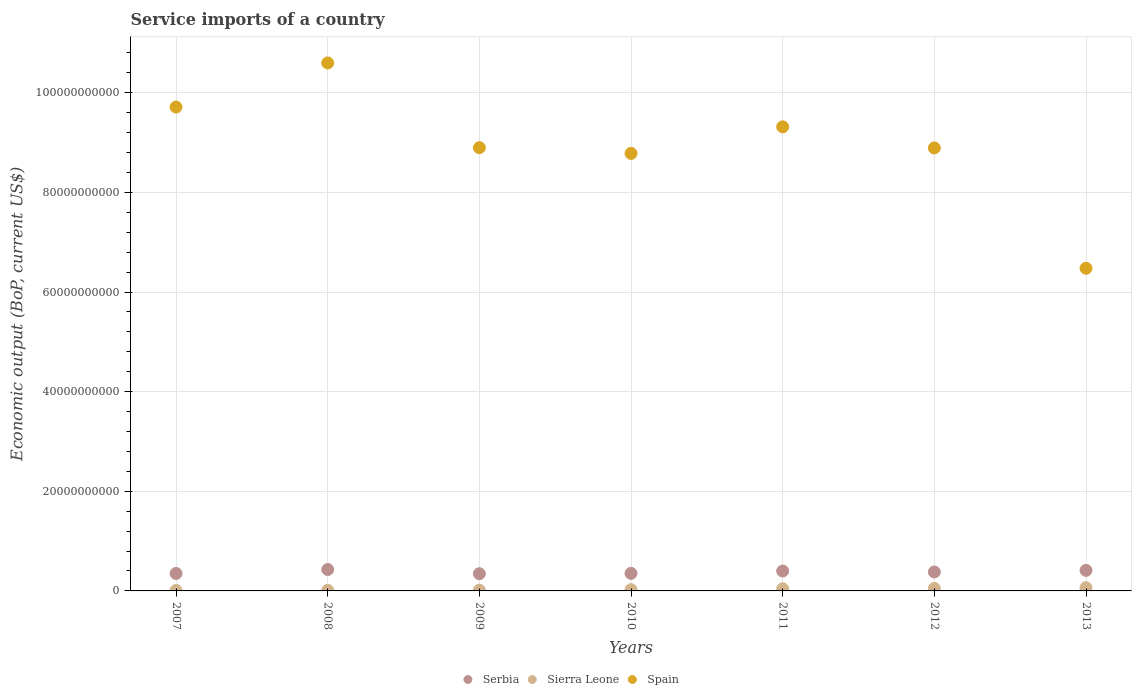Is the number of dotlines equal to the number of legend labels?
Your answer should be compact. Yes. What is the service imports in Serbia in 2010?
Your answer should be very brief. 3.52e+09. Across all years, what is the maximum service imports in Sierra Leone?
Provide a succinct answer. 6.49e+08. Across all years, what is the minimum service imports in Serbia?
Offer a terse response. 3.46e+09. In which year was the service imports in Spain maximum?
Give a very brief answer. 2008. In which year was the service imports in Sierra Leone minimum?
Give a very brief answer. 2007. What is the total service imports in Sierra Leone in the graph?
Your answer should be compact. 2.17e+09. What is the difference between the service imports in Sierra Leone in 2010 and that in 2011?
Give a very brief answer. -1.76e+08. What is the difference between the service imports in Serbia in 2013 and the service imports in Spain in 2007?
Keep it short and to the point. -9.30e+1. What is the average service imports in Sierra Leone per year?
Keep it short and to the point. 3.10e+08. In the year 2013, what is the difference between the service imports in Serbia and service imports in Spain?
Offer a very short reply. -6.06e+1. In how many years, is the service imports in Spain greater than 32000000000 US$?
Your answer should be very brief. 7. What is the ratio of the service imports in Spain in 2008 to that in 2011?
Your answer should be very brief. 1.14. What is the difference between the highest and the second highest service imports in Sierra Leone?
Offer a very short reply. 1.52e+08. What is the difference between the highest and the lowest service imports in Spain?
Ensure brevity in your answer.  4.12e+1. Does the service imports in Spain monotonically increase over the years?
Provide a short and direct response. No. Is the service imports in Spain strictly less than the service imports in Sierra Leone over the years?
Keep it short and to the point. No. Are the values on the major ticks of Y-axis written in scientific E-notation?
Provide a short and direct response. No. How many legend labels are there?
Your answer should be compact. 3. What is the title of the graph?
Ensure brevity in your answer.  Service imports of a country. Does "Chad" appear as one of the legend labels in the graph?
Your response must be concise. No. What is the label or title of the Y-axis?
Your answer should be compact. Economic output (BoP, current US$). What is the Economic output (BoP, current US$) in Serbia in 2007?
Your answer should be very brief. 3.51e+09. What is the Economic output (BoP, current US$) in Sierra Leone in 2007?
Make the answer very short. 9.43e+07. What is the Economic output (BoP, current US$) of Spain in 2007?
Your answer should be very brief. 9.71e+1. What is the Economic output (BoP, current US$) in Serbia in 2008?
Give a very brief answer. 4.30e+09. What is the Economic output (BoP, current US$) of Sierra Leone in 2008?
Your answer should be compact. 1.21e+08. What is the Economic output (BoP, current US$) of Spain in 2008?
Provide a short and direct response. 1.06e+11. What is the Economic output (BoP, current US$) in Serbia in 2009?
Your answer should be compact. 3.46e+09. What is the Economic output (BoP, current US$) in Sierra Leone in 2009?
Provide a succinct answer. 1.32e+08. What is the Economic output (BoP, current US$) in Spain in 2009?
Offer a very short reply. 8.90e+1. What is the Economic output (BoP, current US$) of Serbia in 2010?
Offer a very short reply. 3.52e+09. What is the Economic output (BoP, current US$) in Sierra Leone in 2010?
Your response must be concise. 2.52e+08. What is the Economic output (BoP, current US$) in Spain in 2010?
Your answer should be very brief. 8.78e+1. What is the Economic output (BoP, current US$) in Serbia in 2011?
Offer a very short reply. 3.99e+09. What is the Economic output (BoP, current US$) of Sierra Leone in 2011?
Offer a very short reply. 4.28e+08. What is the Economic output (BoP, current US$) of Spain in 2011?
Your response must be concise. 9.32e+1. What is the Economic output (BoP, current US$) in Serbia in 2012?
Keep it short and to the point. 3.81e+09. What is the Economic output (BoP, current US$) in Sierra Leone in 2012?
Offer a terse response. 4.97e+08. What is the Economic output (BoP, current US$) in Spain in 2012?
Provide a short and direct response. 8.89e+1. What is the Economic output (BoP, current US$) of Serbia in 2013?
Your answer should be very brief. 4.12e+09. What is the Economic output (BoP, current US$) of Sierra Leone in 2013?
Your answer should be compact. 6.49e+08. What is the Economic output (BoP, current US$) in Spain in 2013?
Your response must be concise. 6.48e+1. Across all years, what is the maximum Economic output (BoP, current US$) of Serbia?
Your answer should be very brief. 4.30e+09. Across all years, what is the maximum Economic output (BoP, current US$) in Sierra Leone?
Give a very brief answer. 6.49e+08. Across all years, what is the maximum Economic output (BoP, current US$) of Spain?
Offer a terse response. 1.06e+11. Across all years, what is the minimum Economic output (BoP, current US$) of Serbia?
Offer a very short reply. 3.46e+09. Across all years, what is the minimum Economic output (BoP, current US$) in Sierra Leone?
Offer a very short reply. 9.43e+07. Across all years, what is the minimum Economic output (BoP, current US$) of Spain?
Keep it short and to the point. 6.48e+1. What is the total Economic output (BoP, current US$) of Serbia in the graph?
Offer a terse response. 2.67e+1. What is the total Economic output (BoP, current US$) of Sierra Leone in the graph?
Offer a very short reply. 2.17e+09. What is the total Economic output (BoP, current US$) of Spain in the graph?
Provide a succinct answer. 6.27e+11. What is the difference between the Economic output (BoP, current US$) in Serbia in 2007 and that in 2008?
Your answer should be very brief. -7.91e+08. What is the difference between the Economic output (BoP, current US$) of Sierra Leone in 2007 and that in 2008?
Provide a short and direct response. -2.66e+07. What is the difference between the Economic output (BoP, current US$) of Spain in 2007 and that in 2008?
Your response must be concise. -8.86e+09. What is the difference between the Economic output (BoP, current US$) of Serbia in 2007 and that in 2009?
Give a very brief answer. 4.96e+07. What is the difference between the Economic output (BoP, current US$) of Sierra Leone in 2007 and that in 2009?
Your answer should be compact. -3.78e+07. What is the difference between the Economic output (BoP, current US$) of Spain in 2007 and that in 2009?
Offer a terse response. 8.15e+09. What is the difference between the Economic output (BoP, current US$) of Serbia in 2007 and that in 2010?
Give a very brief answer. -1.85e+07. What is the difference between the Economic output (BoP, current US$) in Sierra Leone in 2007 and that in 2010?
Your answer should be compact. -1.57e+08. What is the difference between the Economic output (BoP, current US$) in Spain in 2007 and that in 2010?
Your answer should be very brief. 9.30e+09. What is the difference between the Economic output (BoP, current US$) of Serbia in 2007 and that in 2011?
Keep it short and to the point. -4.89e+08. What is the difference between the Economic output (BoP, current US$) of Sierra Leone in 2007 and that in 2011?
Your answer should be compact. -3.33e+08. What is the difference between the Economic output (BoP, current US$) in Spain in 2007 and that in 2011?
Provide a succinct answer. 3.97e+09. What is the difference between the Economic output (BoP, current US$) of Serbia in 2007 and that in 2012?
Give a very brief answer. -3.03e+08. What is the difference between the Economic output (BoP, current US$) of Sierra Leone in 2007 and that in 2012?
Offer a terse response. -4.03e+08. What is the difference between the Economic output (BoP, current US$) in Spain in 2007 and that in 2012?
Give a very brief answer. 8.20e+09. What is the difference between the Economic output (BoP, current US$) in Serbia in 2007 and that in 2013?
Your answer should be very brief. -6.19e+08. What is the difference between the Economic output (BoP, current US$) in Sierra Leone in 2007 and that in 2013?
Ensure brevity in your answer.  -5.55e+08. What is the difference between the Economic output (BoP, current US$) in Spain in 2007 and that in 2013?
Make the answer very short. 3.24e+1. What is the difference between the Economic output (BoP, current US$) in Serbia in 2008 and that in 2009?
Make the answer very short. 8.40e+08. What is the difference between the Economic output (BoP, current US$) in Sierra Leone in 2008 and that in 2009?
Provide a short and direct response. -1.11e+07. What is the difference between the Economic output (BoP, current US$) of Spain in 2008 and that in 2009?
Give a very brief answer. 1.70e+1. What is the difference between the Economic output (BoP, current US$) of Serbia in 2008 and that in 2010?
Make the answer very short. 7.72e+08. What is the difference between the Economic output (BoP, current US$) in Sierra Leone in 2008 and that in 2010?
Offer a terse response. -1.31e+08. What is the difference between the Economic output (BoP, current US$) in Spain in 2008 and that in 2010?
Offer a terse response. 1.82e+1. What is the difference between the Economic output (BoP, current US$) in Serbia in 2008 and that in 2011?
Offer a terse response. 3.01e+08. What is the difference between the Economic output (BoP, current US$) of Sierra Leone in 2008 and that in 2011?
Offer a very short reply. -3.07e+08. What is the difference between the Economic output (BoP, current US$) in Spain in 2008 and that in 2011?
Provide a succinct answer. 1.28e+1. What is the difference between the Economic output (BoP, current US$) in Serbia in 2008 and that in 2012?
Ensure brevity in your answer.  4.87e+08. What is the difference between the Economic output (BoP, current US$) in Sierra Leone in 2008 and that in 2012?
Keep it short and to the point. -3.76e+08. What is the difference between the Economic output (BoP, current US$) in Spain in 2008 and that in 2012?
Keep it short and to the point. 1.71e+1. What is the difference between the Economic output (BoP, current US$) in Serbia in 2008 and that in 2013?
Give a very brief answer. 1.72e+08. What is the difference between the Economic output (BoP, current US$) in Sierra Leone in 2008 and that in 2013?
Offer a terse response. -5.28e+08. What is the difference between the Economic output (BoP, current US$) of Spain in 2008 and that in 2013?
Provide a short and direct response. 4.12e+1. What is the difference between the Economic output (BoP, current US$) in Serbia in 2009 and that in 2010?
Your answer should be very brief. -6.81e+07. What is the difference between the Economic output (BoP, current US$) in Sierra Leone in 2009 and that in 2010?
Offer a terse response. -1.20e+08. What is the difference between the Economic output (BoP, current US$) of Spain in 2009 and that in 2010?
Make the answer very short. 1.15e+09. What is the difference between the Economic output (BoP, current US$) in Serbia in 2009 and that in 2011?
Offer a terse response. -5.39e+08. What is the difference between the Economic output (BoP, current US$) in Sierra Leone in 2009 and that in 2011?
Your response must be concise. -2.96e+08. What is the difference between the Economic output (BoP, current US$) of Spain in 2009 and that in 2011?
Offer a terse response. -4.18e+09. What is the difference between the Economic output (BoP, current US$) of Serbia in 2009 and that in 2012?
Your response must be concise. -3.53e+08. What is the difference between the Economic output (BoP, current US$) of Sierra Leone in 2009 and that in 2012?
Offer a very short reply. -3.65e+08. What is the difference between the Economic output (BoP, current US$) in Spain in 2009 and that in 2012?
Offer a terse response. 5.04e+07. What is the difference between the Economic output (BoP, current US$) of Serbia in 2009 and that in 2013?
Keep it short and to the point. -6.68e+08. What is the difference between the Economic output (BoP, current US$) of Sierra Leone in 2009 and that in 2013?
Provide a short and direct response. -5.17e+08. What is the difference between the Economic output (BoP, current US$) of Spain in 2009 and that in 2013?
Ensure brevity in your answer.  2.42e+1. What is the difference between the Economic output (BoP, current US$) of Serbia in 2010 and that in 2011?
Keep it short and to the point. -4.71e+08. What is the difference between the Economic output (BoP, current US$) in Sierra Leone in 2010 and that in 2011?
Give a very brief answer. -1.76e+08. What is the difference between the Economic output (BoP, current US$) in Spain in 2010 and that in 2011?
Your response must be concise. -5.33e+09. What is the difference between the Economic output (BoP, current US$) in Serbia in 2010 and that in 2012?
Offer a terse response. -2.85e+08. What is the difference between the Economic output (BoP, current US$) of Sierra Leone in 2010 and that in 2012?
Your response must be concise. -2.46e+08. What is the difference between the Economic output (BoP, current US$) in Spain in 2010 and that in 2012?
Provide a short and direct response. -1.10e+09. What is the difference between the Economic output (BoP, current US$) of Serbia in 2010 and that in 2013?
Give a very brief answer. -6.00e+08. What is the difference between the Economic output (BoP, current US$) in Sierra Leone in 2010 and that in 2013?
Provide a succinct answer. -3.97e+08. What is the difference between the Economic output (BoP, current US$) in Spain in 2010 and that in 2013?
Your answer should be compact. 2.31e+1. What is the difference between the Economic output (BoP, current US$) of Serbia in 2011 and that in 2012?
Offer a very short reply. 1.86e+08. What is the difference between the Economic output (BoP, current US$) of Sierra Leone in 2011 and that in 2012?
Give a very brief answer. -6.97e+07. What is the difference between the Economic output (BoP, current US$) in Spain in 2011 and that in 2012?
Ensure brevity in your answer.  4.23e+09. What is the difference between the Economic output (BoP, current US$) of Serbia in 2011 and that in 2013?
Your answer should be very brief. -1.30e+08. What is the difference between the Economic output (BoP, current US$) in Sierra Leone in 2011 and that in 2013?
Offer a terse response. -2.21e+08. What is the difference between the Economic output (BoP, current US$) of Spain in 2011 and that in 2013?
Make the answer very short. 2.84e+1. What is the difference between the Economic output (BoP, current US$) of Serbia in 2012 and that in 2013?
Your answer should be very brief. -3.15e+08. What is the difference between the Economic output (BoP, current US$) in Sierra Leone in 2012 and that in 2013?
Give a very brief answer. -1.52e+08. What is the difference between the Economic output (BoP, current US$) of Spain in 2012 and that in 2013?
Your answer should be very brief. 2.42e+1. What is the difference between the Economic output (BoP, current US$) in Serbia in 2007 and the Economic output (BoP, current US$) in Sierra Leone in 2008?
Provide a short and direct response. 3.38e+09. What is the difference between the Economic output (BoP, current US$) in Serbia in 2007 and the Economic output (BoP, current US$) in Spain in 2008?
Offer a terse response. -1.02e+11. What is the difference between the Economic output (BoP, current US$) in Sierra Leone in 2007 and the Economic output (BoP, current US$) in Spain in 2008?
Ensure brevity in your answer.  -1.06e+11. What is the difference between the Economic output (BoP, current US$) of Serbia in 2007 and the Economic output (BoP, current US$) of Sierra Leone in 2009?
Your answer should be compact. 3.37e+09. What is the difference between the Economic output (BoP, current US$) in Serbia in 2007 and the Economic output (BoP, current US$) in Spain in 2009?
Ensure brevity in your answer.  -8.55e+1. What is the difference between the Economic output (BoP, current US$) in Sierra Leone in 2007 and the Economic output (BoP, current US$) in Spain in 2009?
Provide a short and direct response. -8.89e+1. What is the difference between the Economic output (BoP, current US$) of Serbia in 2007 and the Economic output (BoP, current US$) of Sierra Leone in 2010?
Your answer should be very brief. 3.25e+09. What is the difference between the Economic output (BoP, current US$) in Serbia in 2007 and the Economic output (BoP, current US$) in Spain in 2010?
Provide a short and direct response. -8.43e+1. What is the difference between the Economic output (BoP, current US$) of Sierra Leone in 2007 and the Economic output (BoP, current US$) of Spain in 2010?
Make the answer very short. -8.77e+1. What is the difference between the Economic output (BoP, current US$) in Serbia in 2007 and the Economic output (BoP, current US$) in Sierra Leone in 2011?
Your response must be concise. 3.08e+09. What is the difference between the Economic output (BoP, current US$) in Serbia in 2007 and the Economic output (BoP, current US$) in Spain in 2011?
Offer a terse response. -8.97e+1. What is the difference between the Economic output (BoP, current US$) in Sierra Leone in 2007 and the Economic output (BoP, current US$) in Spain in 2011?
Offer a terse response. -9.31e+1. What is the difference between the Economic output (BoP, current US$) in Serbia in 2007 and the Economic output (BoP, current US$) in Sierra Leone in 2012?
Give a very brief answer. 3.01e+09. What is the difference between the Economic output (BoP, current US$) of Serbia in 2007 and the Economic output (BoP, current US$) of Spain in 2012?
Make the answer very short. -8.54e+1. What is the difference between the Economic output (BoP, current US$) of Sierra Leone in 2007 and the Economic output (BoP, current US$) of Spain in 2012?
Keep it short and to the point. -8.88e+1. What is the difference between the Economic output (BoP, current US$) in Serbia in 2007 and the Economic output (BoP, current US$) in Sierra Leone in 2013?
Your answer should be very brief. 2.86e+09. What is the difference between the Economic output (BoP, current US$) in Serbia in 2007 and the Economic output (BoP, current US$) in Spain in 2013?
Your response must be concise. -6.13e+1. What is the difference between the Economic output (BoP, current US$) of Sierra Leone in 2007 and the Economic output (BoP, current US$) of Spain in 2013?
Keep it short and to the point. -6.47e+1. What is the difference between the Economic output (BoP, current US$) of Serbia in 2008 and the Economic output (BoP, current US$) of Sierra Leone in 2009?
Offer a terse response. 4.16e+09. What is the difference between the Economic output (BoP, current US$) in Serbia in 2008 and the Economic output (BoP, current US$) in Spain in 2009?
Make the answer very short. -8.47e+1. What is the difference between the Economic output (BoP, current US$) of Sierra Leone in 2008 and the Economic output (BoP, current US$) of Spain in 2009?
Give a very brief answer. -8.89e+1. What is the difference between the Economic output (BoP, current US$) in Serbia in 2008 and the Economic output (BoP, current US$) in Sierra Leone in 2010?
Your answer should be very brief. 4.04e+09. What is the difference between the Economic output (BoP, current US$) in Serbia in 2008 and the Economic output (BoP, current US$) in Spain in 2010?
Give a very brief answer. -8.35e+1. What is the difference between the Economic output (BoP, current US$) of Sierra Leone in 2008 and the Economic output (BoP, current US$) of Spain in 2010?
Provide a succinct answer. -8.77e+1. What is the difference between the Economic output (BoP, current US$) in Serbia in 2008 and the Economic output (BoP, current US$) in Sierra Leone in 2011?
Ensure brevity in your answer.  3.87e+09. What is the difference between the Economic output (BoP, current US$) of Serbia in 2008 and the Economic output (BoP, current US$) of Spain in 2011?
Offer a very short reply. -8.89e+1. What is the difference between the Economic output (BoP, current US$) in Sierra Leone in 2008 and the Economic output (BoP, current US$) in Spain in 2011?
Make the answer very short. -9.30e+1. What is the difference between the Economic output (BoP, current US$) of Serbia in 2008 and the Economic output (BoP, current US$) of Sierra Leone in 2012?
Offer a terse response. 3.80e+09. What is the difference between the Economic output (BoP, current US$) in Serbia in 2008 and the Economic output (BoP, current US$) in Spain in 2012?
Offer a very short reply. -8.46e+1. What is the difference between the Economic output (BoP, current US$) in Sierra Leone in 2008 and the Economic output (BoP, current US$) in Spain in 2012?
Your response must be concise. -8.88e+1. What is the difference between the Economic output (BoP, current US$) in Serbia in 2008 and the Economic output (BoP, current US$) in Sierra Leone in 2013?
Offer a terse response. 3.65e+09. What is the difference between the Economic output (BoP, current US$) in Serbia in 2008 and the Economic output (BoP, current US$) in Spain in 2013?
Ensure brevity in your answer.  -6.05e+1. What is the difference between the Economic output (BoP, current US$) of Sierra Leone in 2008 and the Economic output (BoP, current US$) of Spain in 2013?
Provide a succinct answer. -6.46e+1. What is the difference between the Economic output (BoP, current US$) in Serbia in 2009 and the Economic output (BoP, current US$) in Sierra Leone in 2010?
Your answer should be compact. 3.20e+09. What is the difference between the Economic output (BoP, current US$) of Serbia in 2009 and the Economic output (BoP, current US$) of Spain in 2010?
Ensure brevity in your answer.  -8.44e+1. What is the difference between the Economic output (BoP, current US$) in Sierra Leone in 2009 and the Economic output (BoP, current US$) in Spain in 2010?
Give a very brief answer. -8.77e+1. What is the difference between the Economic output (BoP, current US$) in Serbia in 2009 and the Economic output (BoP, current US$) in Sierra Leone in 2011?
Give a very brief answer. 3.03e+09. What is the difference between the Economic output (BoP, current US$) of Serbia in 2009 and the Economic output (BoP, current US$) of Spain in 2011?
Provide a succinct answer. -8.97e+1. What is the difference between the Economic output (BoP, current US$) of Sierra Leone in 2009 and the Economic output (BoP, current US$) of Spain in 2011?
Offer a very short reply. -9.30e+1. What is the difference between the Economic output (BoP, current US$) in Serbia in 2009 and the Economic output (BoP, current US$) in Sierra Leone in 2012?
Your answer should be compact. 2.96e+09. What is the difference between the Economic output (BoP, current US$) of Serbia in 2009 and the Economic output (BoP, current US$) of Spain in 2012?
Keep it short and to the point. -8.55e+1. What is the difference between the Economic output (BoP, current US$) of Sierra Leone in 2009 and the Economic output (BoP, current US$) of Spain in 2012?
Your response must be concise. -8.88e+1. What is the difference between the Economic output (BoP, current US$) of Serbia in 2009 and the Economic output (BoP, current US$) of Sierra Leone in 2013?
Your answer should be compact. 2.81e+09. What is the difference between the Economic output (BoP, current US$) of Serbia in 2009 and the Economic output (BoP, current US$) of Spain in 2013?
Your answer should be very brief. -6.13e+1. What is the difference between the Economic output (BoP, current US$) in Sierra Leone in 2009 and the Economic output (BoP, current US$) in Spain in 2013?
Make the answer very short. -6.46e+1. What is the difference between the Economic output (BoP, current US$) in Serbia in 2010 and the Economic output (BoP, current US$) in Sierra Leone in 2011?
Ensure brevity in your answer.  3.10e+09. What is the difference between the Economic output (BoP, current US$) in Serbia in 2010 and the Economic output (BoP, current US$) in Spain in 2011?
Provide a succinct answer. -8.96e+1. What is the difference between the Economic output (BoP, current US$) of Sierra Leone in 2010 and the Economic output (BoP, current US$) of Spain in 2011?
Offer a very short reply. -9.29e+1. What is the difference between the Economic output (BoP, current US$) of Serbia in 2010 and the Economic output (BoP, current US$) of Sierra Leone in 2012?
Offer a very short reply. 3.03e+09. What is the difference between the Economic output (BoP, current US$) in Serbia in 2010 and the Economic output (BoP, current US$) in Spain in 2012?
Offer a terse response. -8.54e+1. What is the difference between the Economic output (BoP, current US$) of Sierra Leone in 2010 and the Economic output (BoP, current US$) of Spain in 2012?
Your answer should be very brief. -8.87e+1. What is the difference between the Economic output (BoP, current US$) in Serbia in 2010 and the Economic output (BoP, current US$) in Sierra Leone in 2013?
Make the answer very short. 2.88e+09. What is the difference between the Economic output (BoP, current US$) in Serbia in 2010 and the Economic output (BoP, current US$) in Spain in 2013?
Provide a short and direct response. -6.12e+1. What is the difference between the Economic output (BoP, current US$) in Sierra Leone in 2010 and the Economic output (BoP, current US$) in Spain in 2013?
Your response must be concise. -6.45e+1. What is the difference between the Economic output (BoP, current US$) in Serbia in 2011 and the Economic output (BoP, current US$) in Sierra Leone in 2012?
Your response must be concise. 3.50e+09. What is the difference between the Economic output (BoP, current US$) of Serbia in 2011 and the Economic output (BoP, current US$) of Spain in 2012?
Give a very brief answer. -8.49e+1. What is the difference between the Economic output (BoP, current US$) in Sierra Leone in 2011 and the Economic output (BoP, current US$) in Spain in 2012?
Your answer should be compact. -8.85e+1. What is the difference between the Economic output (BoP, current US$) in Serbia in 2011 and the Economic output (BoP, current US$) in Sierra Leone in 2013?
Ensure brevity in your answer.  3.35e+09. What is the difference between the Economic output (BoP, current US$) in Serbia in 2011 and the Economic output (BoP, current US$) in Spain in 2013?
Your answer should be compact. -6.08e+1. What is the difference between the Economic output (BoP, current US$) in Sierra Leone in 2011 and the Economic output (BoP, current US$) in Spain in 2013?
Make the answer very short. -6.43e+1. What is the difference between the Economic output (BoP, current US$) in Serbia in 2012 and the Economic output (BoP, current US$) in Sierra Leone in 2013?
Provide a short and direct response. 3.16e+09. What is the difference between the Economic output (BoP, current US$) of Serbia in 2012 and the Economic output (BoP, current US$) of Spain in 2013?
Provide a short and direct response. -6.10e+1. What is the difference between the Economic output (BoP, current US$) of Sierra Leone in 2012 and the Economic output (BoP, current US$) of Spain in 2013?
Offer a terse response. -6.43e+1. What is the average Economic output (BoP, current US$) of Serbia per year?
Ensure brevity in your answer.  3.82e+09. What is the average Economic output (BoP, current US$) in Sierra Leone per year?
Provide a short and direct response. 3.10e+08. What is the average Economic output (BoP, current US$) of Spain per year?
Provide a short and direct response. 8.95e+1. In the year 2007, what is the difference between the Economic output (BoP, current US$) of Serbia and Economic output (BoP, current US$) of Sierra Leone?
Keep it short and to the point. 3.41e+09. In the year 2007, what is the difference between the Economic output (BoP, current US$) in Serbia and Economic output (BoP, current US$) in Spain?
Provide a succinct answer. -9.36e+1. In the year 2007, what is the difference between the Economic output (BoP, current US$) in Sierra Leone and Economic output (BoP, current US$) in Spain?
Give a very brief answer. -9.70e+1. In the year 2008, what is the difference between the Economic output (BoP, current US$) in Serbia and Economic output (BoP, current US$) in Sierra Leone?
Ensure brevity in your answer.  4.18e+09. In the year 2008, what is the difference between the Economic output (BoP, current US$) of Serbia and Economic output (BoP, current US$) of Spain?
Provide a short and direct response. -1.02e+11. In the year 2008, what is the difference between the Economic output (BoP, current US$) of Sierra Leone and Economic output (BoP, current US$) of Spain?
Your answer should be compact. -1.06e+11. In the year 2009, what is the difference between the Economic output (BoP, current US$) in Serbia and Economic output (BoP, current US$) in Sierra Leone?
Ensure brevity in your answer.  3.32e+09. In the year 2009, what is the difference between the Economic output (BoP, current US$) in Serbia and Economic output (BoP, current US$) in Spain?
Your answer should be very brief. -8.55e+1. In the year 2009, what is the difference between the Economic output (BoP, current US$) in Sierra Leone and Economic output (BoP, current US$) in Spain?
Offer a very short reply. -8.88e+1. In the year 2010, what is the difference between the Economic output (BoP, current US$) of Serbia and Economic output (BoP, current US$) of Sierra Leone?
Provide a short and direct response. 3.27e+09. In the year 2010, what is the difference between the Economic output (BoP, current US$) of Serbia and Economic output (BoP, current US$) of Spain?
Offer a very short reply. -8.43e+1. In the year 2010, what is the difference between the Economic output (BoP, current US$) of Sierra Leone and Economic output (BoP, current US$) of Spain?
Give a very brief answer. -8.76e+1. In the year 2011, what is the difference between the Economic output (BoP, current US$) of Serbia and Economic output (BoP, current US$) of Sierra Leone?
Your response must be concise. 3.57e+09. In the year 2011, what is the difference between the Economic output (BoP, current US$) in Serbia and Economic output (BoP, current US$) in Spain?
Give a very brief answer. -8.92e+1. In the year 2011, what is the difference between the Economic output (BoP, current US$) of Sierra Leone and Economic output (BoP, current US$) of Spain?
Ensure brevity in your answer.  -9.27e+1. In the year 2012, what is the difference between the Economic output (BoP, current US$) in Serbia and Economic output (BoP, current US$) in Sierra Leone?
Ensure brevity in your answer.  3.31e+09. In the year 2012, what is the difference between the Economic output (BoP, current US$) in Serbia and Economic output (BoP, current US$) in Spain?
Give a very brief answer. -8.51e+1. In the year 2012, what is the difference between the Economic output (BoP, current US$) in Sierra Leone and Economic output (BoP, current US$) in Spain?
Give a very brief answer. -8.84e+1. In the year 2013, what is the difference between the Economic output (BoP, current US$) of Serbia and Economic output (BoP, current US$) of Sierra Leone?
Your response must be concise. 3.48e+09. In the year 2013, what is the difference between the Economic output (BoP, current US$) in Serbia and Economic output (BoP, current US$) in Spain?
Your response must be concise. -6.06e+1. In the year 2013, what is the difference between the Economic output (BoP, current US$) of Sierra Leone and Economic output (BoP, current US$) of Spain?
Your answer should be compact. -6.41e+1. What is the ratio of the Economic output (BoP, current US$) in Serbia in 2007 to that in 2008?
Offer a very short reply. 0.82. What is the ratio of the Economic output (BoP, current US$) of Sierra Leone in 2007 to that in 2008?
Your answer should be very brief. 0.78. What is the ratio of the Economic output (BoP, current US$) of Spain in 2007 to that in 2008?
Provide a short and direct response. 0.92. What is the ratio of the Economic output (BoP, current US$) in Serbia in 2007 to that in 2009?
Provide a succinct answer. 1.01. What is the ratio of the Economic output (BoP, current US$) of Sierra Leone in 2007 to that in 2009?
Offer a very short reply. 0.71. What is the ratio of the Economic output (BoP, current US$) of Spain in 2007 to that in 2009?
Your response must be concise. 1.09. What is the ratio of the Economic output (BoP, current US$) of Serbia in 2007 to that in 2010?
Provide a short and direct response. 0.99. What is the ratio of the Economic output (BoP, current US$) in Sierra Leone in 2007 to that in 2010?
Provide a short and direct response. 0.37. What is the ratio of the Economic output (BoP, current US$) of Spain in 2007 to that in 2010?
Provide a short and direct response. 1.11. What is the ratio of the Economic output (BoP, current US$) in Serbia in 2007 to that in 2011?
Your answer should be compact. 0.88. What is the ratio of the Economic output (BoP, current US$) of Sierra Leone in 2007 to that in 2011?
Your answer should be very brief. 0.22. What is the ratio of the Economic output (BoP, current US$) in Spain in 2007 to that in 2011?
Provide a short and direct response. 1.04. What is the ratio of the Economic output (BoP, current US$) in Serbia in 2007 to that in 2012?
Provide a short and direct response. 0.92. What is the ratio of the Economic output (BoP, current US$) in Sierra Leone in 2007 to that in 2012?
Provide a short and direct response. 0.19. What is the ratio of the Economic output (BoP, current US$) of Spain in 2007 to that in 2012?
Offer a very short reply. 1.09. What is the ratio of the Economic output (BoP, current US$) in Sierra Leone in 2007 to that in 2013?
Keep it short and to the point. 0.15. What is the ratio of the Economic output (BoP, current US$) in Spain in 2007 to that in 2013?
Provide a short and direct response. 1.5. What is the ratio of the Economic output (BoP, current US$) of Serbia in 2008 to that in 2009?
Your answer should be very brief. 1.24. What is the ratio of the Economic output (BoP, current US$) in Sierra Leone in 2008 to that in 2009?
Provide a short and direct response. 0.92. What is the ratio of the Economic output (BoP, current US$) in Spain in 2008 to that in 2009?
Provide a short and direct response. 1.19. What is the ratio of the Economic output (BoP, current US$) in Serbia in 2008 to that in 2010?
Provide a short and direct response. 1.22. What is the ratio of the Economic output (BoP, current US$) of Sierra Leone in 2008 to that in 2010?
Your answer should be very brief. 0.48. What is the ratio of the Economic output (BoP, current US$) in Spain in 2008 to that in 2010?
Your answer should be compact. 1.21. What is the ratio of the Economic output (BoP, current US$) of Serbia in 2008 to that in 2011?
Provide a short and direct response. 1.08. What is the ratio of the Economic output (BoP, current US$) in Sierra Leone in 2008 to that in 2011?
Provide a succinct answer. 0.28. What is the ratio of the Economic output (BoP, current US$) of Spain in 2008 to that in 2011?
Offer a terse response. 1.14. What is the ratio of the Economic output (BoP, current US$) in Serbia in 2008 to that in 2012?
Your response must be concise. 1.13. What is the ratio of the Economic output (BoP, current US$) of Sierra Leone in 2008 to that in 2012?
Offer a very short reply. 0.24. What is the ratio of the Economic output (BoP, current US$) in Spain in 2008 to that in 2012?
Give a very brief answer. 1.19. What is the ratio of the Economic output (BoP, current US$) of Serbia in 2008 to that in 2013?
Offer a terse response. 1.04. What is the ratio of the Economic output (BoP, current US$) in Sierra Leone in 2008 to that in 2013?
Your response must be concise. 0.19. What is the ratio of the Economic output (BoP, current US$) of Spain in 2008 to that in 2013?
Provide a succinct answer. 1.64. What is the ratio of the Economic output (BoP, current US$) in Serbia in 2009 to that in 2010?
Give a very brief answer. 0.98. What is the ratio of the Economic output (BoP, current US$) in Sierra Leone in 2009 to that in 2010?
Provide a succinct answer. 0.53. What is the ratio of the Economic output (BoP, current US$) in Spain in 2009 to that in 2010?
Your answer should be very brief. 1.01. What is the ratio of the Economic output (BoP, current US$) of Serbia in 2009 to that in 2011?
Give a very brief answer. 0.87. What is the ratio of the Economic output (BoP, current US$) in Sierra Leone in 2009 to that in 2011?
Offer a terse response. 0.31. What is the ratio of the Economic output (BoP, current US$) in Spain in 2009 to that in 2011?
Your response must be concise. 0.96. What is the ratio of the Economic output (BoP, current US$) of Serbia in 2009 to that in 2012?
Offer a terse response. 0.91. What is the ratio of the Economic output (BoP, current US$) of Sierra Leone in 2009 to that in 2012?
Provide a short and direct response. 0.27. What is the ratio of the Economic output (BoP, current US$) in Spain in 2009 to that in 2012?
Your response must be concise. 1. What is the ratio of the Economic output (BoP, current US$) in Serbia in 2009 to that in 2013?
Make the answer very short. 0.84. What is the ratio of the Economic output (BoP, current US$) of Sierra Leone in 2009 to that in 2013?
Make the answer very short. 0.2. What is the ratio of the Economic output (BoP, current US$) in Spain in 2009 to that in 2013?
Your answer should be very brief. 1.37. What is the ratio of the Economic output (BoP, current US$) of Serbia in 2010 to that in 2011?
Offer a very short reply. 0.88. What is the ratio of the Economic output (BoP, current US$) in Sierra Leone in 2010 to that in 2011?
Offer a very short reply. 0.59. What is the ratio of the Economic output (BoP, current US$) in Spain in 2010 to that in 2011?
Your answer should be very brief. 0.94. What is the ratio of the Economic output (BoP, current US$) in Serbia in 2010 to that in 2012?
Provide a short and direct response. 0.93. What is the ratio of the Economic output (BoP, current US$) of Sierra Leone in 2010 to that in 2012?
Offer a terse response. 0.51. What is the ratio of the Economic output (BoP, current US$) of Spain in 2010 to that in 2012?
Your answer should be very brief. 0.99. What is the ratio of the Economic output (BoP, current US$) of Serbia in 2010 to that in 2013?
Provide a succinct answer. 0.85. What is the ratio of the Economic output (BoP, current US$) in Sierra Leone in 2010 to that in 2013?
Offer a very short reply. 0.39. What is the ratio of the Economic output (BoP, current US$) of Spain in 2010 to that in 2013?
Offer a very short reply. 1.36. What is the ratio of the Economic output (BoP, current US$) in Serbia in 2011 to that in 2012?
Your answer should be very brief. 1.05. What is the ratio of the Economic output (BoP, current US$) of Sierra Leone in 2011 to that in 2012?
Keep it short and to the point. 0.86. What is the ratio of the Economic output (BoP, current US$) of Spain in 2011 to that in 2012?
Make the answer very short. 1.05. What is the ratio of the Economic output (BoP, current US$) of Serbia in 2011 to that in 2013?
Your answer should be compact. 0.97. What is the ratio of the Economic output (BoP, current US$) in Sierra Leone in 2011 to that in 2013?
Offer a very short reply. 0.66. What is the ratio of the Economic output (BoP, current US$) of Spain in 2011 to that in 2013?
Your response must be concise. 1.44. What is the ratio of the Economic output (BoP, current US$) of Serbia in 2012 to that in 2013?
Give a very brief answer. 0.92. What is the ratio of the Economic output (BoP, current US$) of Sierra Leone in 2012 to that in 2013?
Make the answer very short. 0.77. What is the ratio of the Economic output (BoP, current US$) of Spain in 2012 to that in 2013?
Offer a very short reply. 1.37. What is the difference between the highest and the second highest Economic output (BoP, current US$) in Serbia?
Your response must be concise. 1.72e+08. What is the difference between the highest and the second highest Economic output (BoP, current US$) of Sierra Leone?
Offer a terse response. 1.52e+08. What is the difference between the highest and the second highest Economic output (BoP, current US$) of Spain?
Your response must be concise. 8.86e+09. What is the difference between the highest and the lowest Economic output (BoP, current US$) of Serbia?
Keep it short and to the point. 8.40e+08. What is the difference between the highest and the lowest Economic output (BoP, current US$) in Sierra Leone?
Provide a short and direct response. 5.55e+08. What is the difference between the highest and the lowest Economic output (BoP, current US$) of Spain?
Provide a succinct answer. 4.12e+1. 